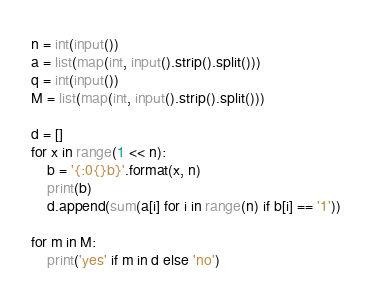Convert code to text. <code><loc_0><loc_0><loc_500><loc_500><_Python_>n = int(input())
a = list(map(int, input().strip().split()))
q = int(input())
M = list(map(int, input().strip().split()))

d = []
for x in range(1 << n):
    b = '{:0{}b}'.format(x, n)
    print(b)
    d.append(sum(a[i] for i in range(n) if b[i] == '1'))

for m in M:
    print('yes' if m in d else 'no')</code> 